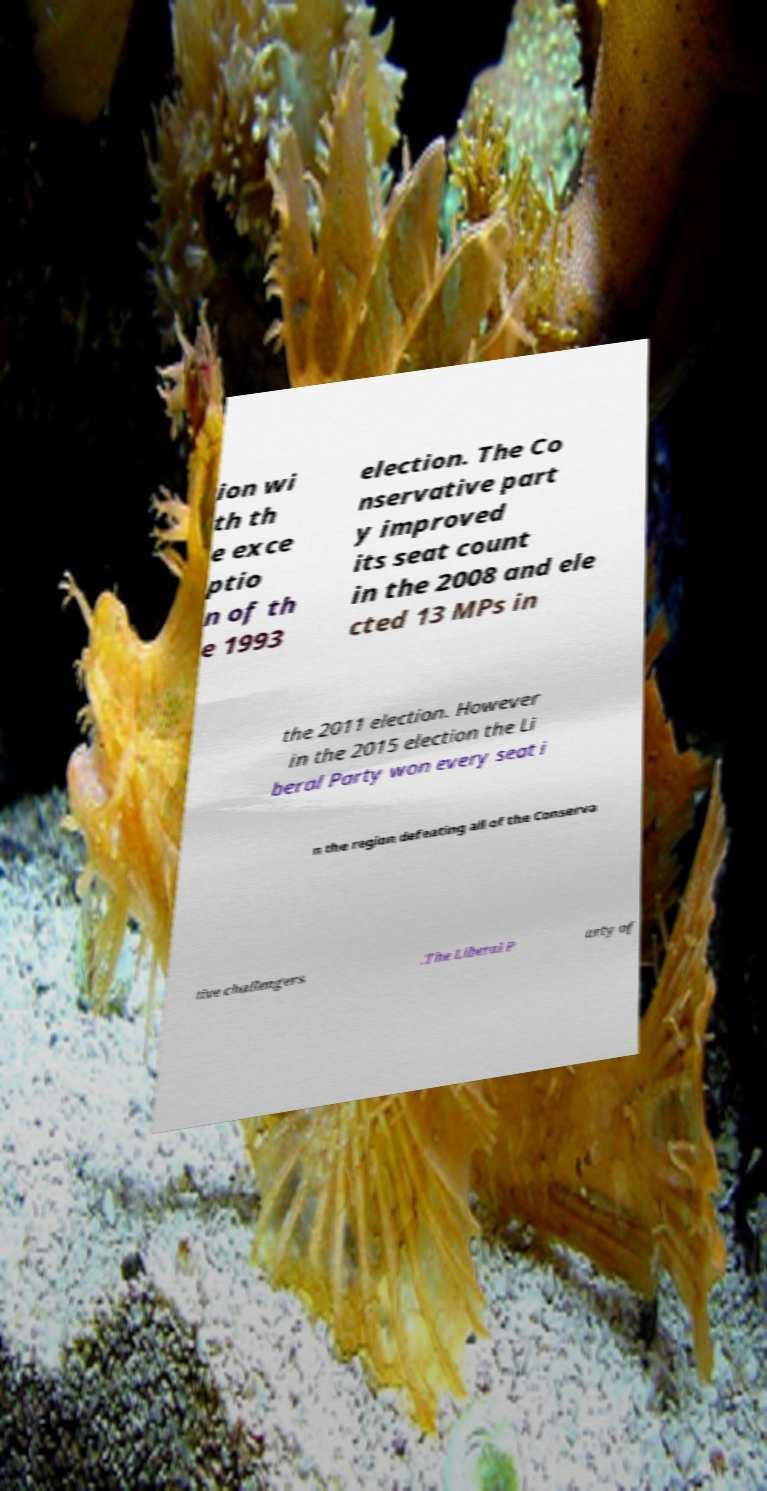There's text embedded in this image that I need extracted. Can you transcribe it verbatim? ion wi th th e exce ptio n of th e 1993 election. The Co nservative part y improved its seat count in the 2008 and ele cted 13 MPs in the 2011 election. However in the 2015 election the Li beral Party won every seat i n the region defeating all of the Conserva tive challengers .The Liberal P arty of 